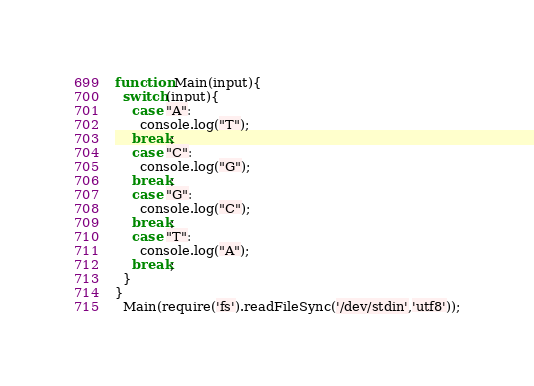<code> <loc_0><loc_0><loc_500><loc_500><_JavaScript_>function Main(input){ 
  switch(input){
    case "A":
      console.log("T");
    break;
    case "C":
      console.log("G");
    break;
    case "G":
      console.log("C");
    break;
    case "T":
      console.log("A");
    break;
  }
}
  Main(require('fs').readFileSync('/dev/stdin','utf8'));</code> 